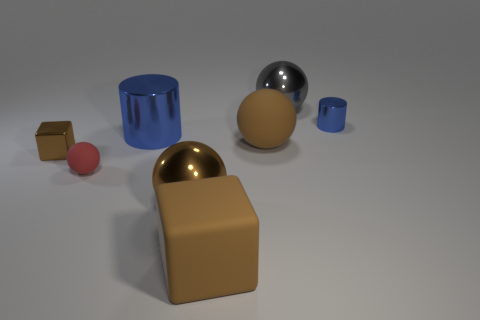Add 1 gray metallic cylinders. How many objects exist? 9 Subtract all cylinders. How many objects are left? 6 Subtract 2 blue cylinders. How many objects are left? 6 Subtract all blue metallic objects. Subtract all metallic balls. How many objects are left? 4 Add 2 shiny objects. How many shiny objects are left? 7 Add 8 big cyan things. How many big cyan things exist? 8 